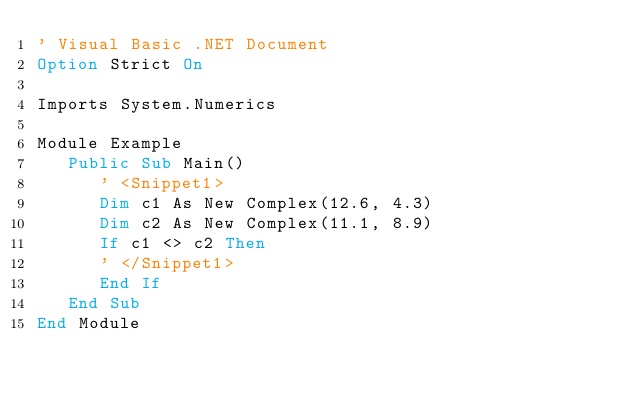Convert code to text. <code><loc_0><loc_0><loc_500><loc_500><_VisualBasic_>' Visual Basic .NET Document
Option Strict On

Imports System.Numerics

Module Example
   Public Sub Main()
      ' <Snippet1>
      Dim c1 As New Complex(12.6, 4.3)
      Dim c2 As New Complex(11.1, 8.9)
      If c1 <> c2 Then 
      ' </Snippet1>
      End If      
   End Sub
End Module

</code> 